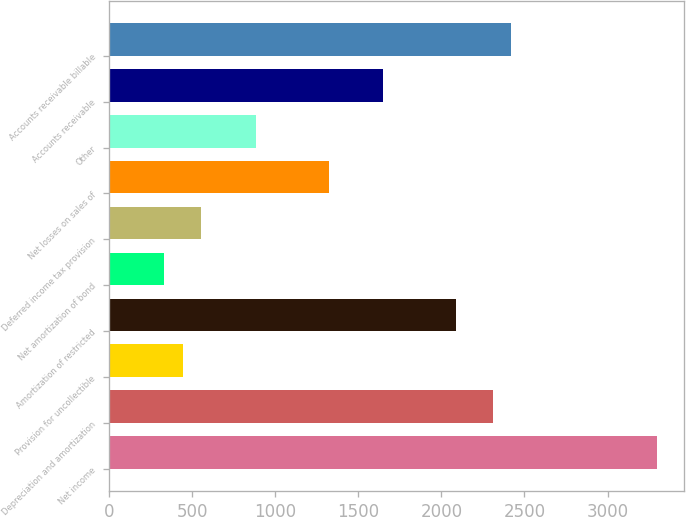<chart> <loc_0><loc_0><loc_500><loc_500><bar_chart><fcel>Net income<fcel>Depreciation and amortization<fcel>Provision for uncollectible<fcel>Amortization of restricted<fcel>Net amortization of bond<fcel>Deferred income tax provision<fcel>Net losses on sales of<fcel>Other<fcel>Accounts receivable<fcel>Accounts receivable billable<nl><fcel>3297.43<fcel>2308.69<fcel>441.07<fcel>2088.97<fcel>331.21<fcel>550.93<fcel>1319.95<fcel>880.51<fcel>1649.53<fcel>2418.55<nl></chart> 